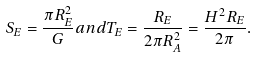Convert formula to latex. <formula><loc_0><loc_0><loc_500><loc_500>S _ { E } = \frac { \pi R _ { E } ^ { 2 } } { G } a n d T _ { E } = \frac { R _ { E } } { 2 \pi R _ { A } ^ { 2 } } = \frac { H ^ { 2 } R _ { E } } { 2 \pi } .</formula> 